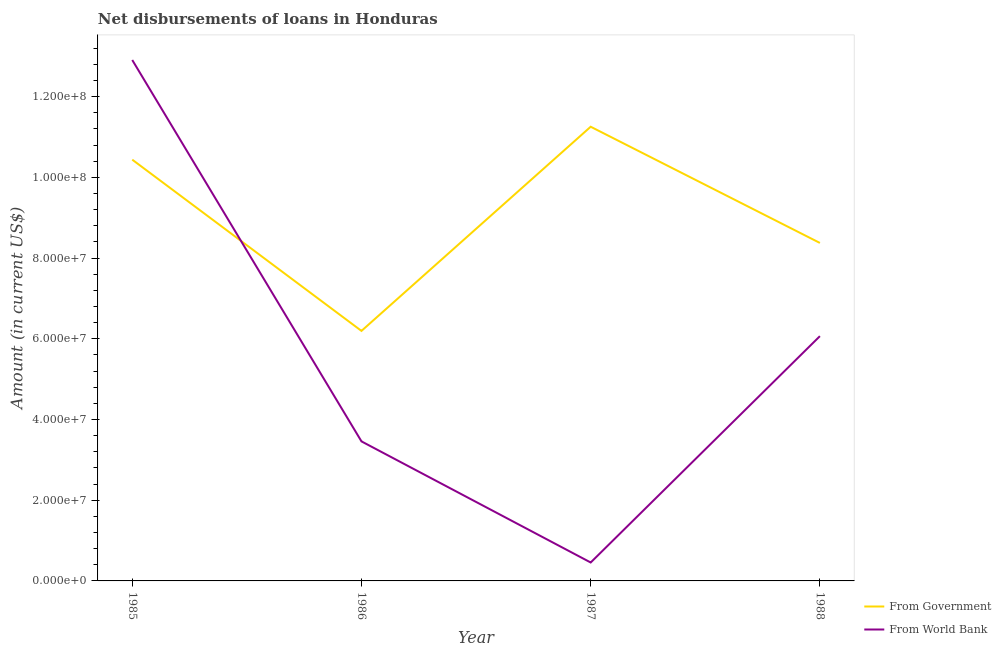How many different coloured lines are there?
Ensure brevity in your answer.  2. Does the line corresponding to net disbursements of loan from world bank intersect with the line corresponding to net disbursements of loan from government?
Give a very brief answer. Yes. Is the number of lines equal to the number of legend labels?
Your answer should be very brief. Yes. What is the net disbursements of loan from world bank in 1986?
Provide a short and direct response. 3.46e+07. Across all years, what is the maximum net disbursements of loan from world bank?
Ensure brevity in your answer.  1.29e+08. Across all years, what is the minimum net disbursements of loan from world bank?
Your answer should be very brief. 4.57e+06. In which year was the net disbursements of loan from world bank maximum?
Your response must be concise. 1985. In which year was the net disbursements of loan from world bank minimum?
Your answer should be very brief. 1987. What is the total net disbursements of loan from world bank in the graph?
Provide a short and direct response. 2.29e+08. What is the difference between the net disbursements of loan from government in 1985 and that in 1987?
Give a very brief answer. -8.16e+06. What is the difference between the net disbursements of loan from world bank in 1986 and the net disbursements of loan from government in 1987?
Ensure brevity in your answer.  -7.80e+07. What is the average net disbursements of loan from government per year?
Provide a short and direct response. 9.07e+07. In the year 1986, what is the difference between the net disbursements of loan from government and net disbursements of loan from world bank?
Your answer should be compact. 2.74e+07. What is the ratio of the net disbursements of loan from world bank in 1985 to that in 1988?
Provide a short and direct response. 2.13. Is the net disbursements of loan from government in 1987 less than that in 1988?
Make the answer very short. No. Is the difference between the net disbursements of loan from world bank in 1985 and 1986 greater than the difference between the net disbursements of loan from government in 1985 and 1986?
Offer a very short reply. Yes. What is the difference between the highest and the second highest net disbursements of loan from world bank?
Provide a short and direct response. 6.84e+07. What is the difference between the highest and the lowest net disbursements of loan from world bank?
Your answer should be very brief. 1.25e+08. In how many years, is the net disbursements of loan from world bank greater than the average net disbursements of loan from world bank taken over all years?
Offer a very short reply. 2. Is the sum of the net disbursements of loan from world bank in 1987 and 1988 greater than the maximum net disbursements of loan from government across all years?
Provide a short and direct response. No. How many lines are there?
Offer a terse response. 2. How many years are there in the graph?
Make the answer very short. 4. What is the difference between two consecutive major ticks on the Y-axis?
Provide a short and direct response. 2.00e+07. Are the values on the major ticks of Y-axis written in scientific E-notation?
Your answer should be compact. Yes. Does the graph contain any zero values?
Your answer should be compact. No. Does the graph contain grids?
Your response must be concise. No. How many legend labels are there?
Offer a terse response. 2. How are the legend labels stacked?
Your response must be concise. Vertical. What is the title of the graph?
Ensure brevity in your answer.  Net disbursements of loans in Honduras. Does "Lowest 20% of population" appear as one of the legend labels in the graph?
Keep it short and to the point. No. What is the Amount (in current US$) in From Government in 1985?
Offer a terse response. 1.04e+08. What is the Amount (in current US$) in From World Bank in 1985?
Provide a short and direct response. 1.29e+08. What is the Amount (in current US$) in From Government in 1986?
Provide a short and direct response. 6.20e+07. What is the Amount (in current US$) of From World Bank in 1986?
Your response must be concise. 3.46e+07. What is the Amount (in current US$) of From Government in 1987?
Provide a short and direct response. 1.13e+08. What is the Amount (in current US$) of From World Bank in 1987?
Offer a very short reply. 4.57e+06. What is the Amount (in current US$) in From Government in 1988?
Your answer should be very brief. 8.38e+07. What is the Amount (in current US$) of From World Bank in 1988?
Keep it short and to the point. 6.07e+07. Across all years, what is the maximum Amount (in current US$) of From Government?
Make the answer very short. 1.13e+08. Across all years, what is the maximum Amount (in current US$) in From World Bank?
Ensure brevity in your answer.  1.29e+08. Across all years, what is the minimum Amount (in current US$) of From Government?
Offer a very short reply. 6.20e+07. Across all years, what is the minimum Amount (in current US$) of From World Bank?
Provide a succinct answer. 4.57e+06. What is the total Amount (in current US$) in From Government in the graph?
Give a very brief answer. 3.63e+08. What is the total Amount (in current US$) of From World Bank in the graph?
Your response must be concise. 2.29e+08. What is the difference between the Amount (in current US$) in From Government in 1985 and that in 1986?
Ensure brevity in your answer.  4.24e+07. What is the difference between the Amount (in current US$) in From World Bank in 1985 and that in 1986?
Make the answer very short. 9.45e+07. What is the difference between the Amount (in current US$) in From Government in 1985 and that in 1987?
Your answer should be very brief. -8.16e+06. What is the difference between the Amount (in current US$) in From World Bank in 1985 and that in 1987?
Provide a short and direct response. 1.25e+08. What is the difference between the Amount (in current US$) of From Government in 1985 and that in 1988?
Offer a terse response. 2.06e+07. What is the difference between the Amount (in current US$) of From World Bank in 1985 and that in 1988?
Ensure brevity in your answer.  6.84e+07. What is the difference between the Amount (in current US$) of From Government in 1986 and that in 1987?
Provide a short and direct response. -5.06e+07. What is the difference between the Amount (in current US$) in From World Bank in 1986 and that in 1987?
Offer a very short reply. 3.00e+07. What is the difference between the Amount (in current US$) in From Government in 1986 and that in 1988?
Make the answer very short. -2.18e+07. What is the difference between the Amount (in current US$) of From World Bank in 1986 and that in 1988?
Your answer should be compact. -2.61e+07. What is the difference between the Amount (in current US$) in From Government in 1987 and that in 1988?
Offer a very short reply. 2.88e+07. What is the difference between the Amount (in current US$) in From World Bank in 1987 and that in 1988?
Your response must be concise. -5.61e+07. What is the difference between the Amount (in current US$) in From Government in 1985 and the Amount (in current US$) in From World Bank in 1986?
Offer a very short reply. 6.98e+07. What is the difference between the Amount (in current US$) of From Government in 1985 and the Amount (in current US$) of From World Bank in 1987?
Offer a very short reply. 9.98e+07. What is the difference between the Amount (in current US$) in From Government in 1985 and the Amount (in current US$) in From World Bank in 1988?
Your answer should be very brief. 4.37e+07. What is the difference between the Amount (in current US$) of From Government in 1986 and the Amount (in current US$) of From World Bank in 1987?
Your answer should be very brief. 5.74e+07. What is the difference between the Amount (in current US$) of From Government in 1986 and the Amount (in current US$) of From World Bank in 1988?
Give a very brief answer. 1.30e+06. What is the difference between the Amount (in current US$) of From Government in 1987 and the Amount (in current US$) of From World Bank in 1988?
Offer a terse response. 5.19e+07. What is the average Amount (in current US$) in From Government per year?
Offer a terse response. 9.07e+07. What is the average Amount (in current US$) in From World Bank per year?
Your answer should be compact. 5.72e+07. In the year 1985, what is the difference between the Amount (in current US$) in From Government and Amount (in current US$) in From World Bank?
Your response must be concise. -2.47e+07. In the year 1986, what is the difference between the Amount (in current US$) of From Government and Amount (in current US$) of From World Bank?
Give a very brief answer. 2.74e+07. In the year 1987, what is the difference between the Amount (in current US$) of From Government and Amount (in current US$) of From World Bank?
Make the answer very short. 1.08e+08. In the year 1988, what is the difference between the Amount (in current US$) in From Government and Amount (in current US$) in From World Bank?
Make the answer very short. 2.31e+07. What is the ratio of the Amount (in current US$) in From Government in 1985 to that in 1986?
Ensure brevity in your answer.  1.69. What is the ratio of the Amount (in current US$) in From World Bank in 1985 to that in 1986?
Provide a succinct answer. 3.73. What is the ratio of the Amount (in current US$) in From Government in 1985 to that in 1987?
Give a very brief answer. 0.93. What is the ratio of the Amount (in current US$) in From World Bank in 1985 to that in 1987?
Offer a very short reply. 28.26. What is the ratio of the Amount (in current US$) of From Government in 1985 to that in 1988?
Your response must be concise. 1.25. What is the ratio of the Amount (in current US$) in From World Bank in 1985 to that in 1988?
Your answer should be very brief. 2.13. What is the ratio of the Amount (in current US$) of From Government in 1986 to that in 1987?
Keep it short and to the point. 0.55. What is the ratio of the Amount (in current US$) of From World Bank in 1986 to that in 1987?
Make the answer very short. 7.57. What is the ratio of the Amount (in current US$) in From Government in 1986 to that in 1988?
Ensure brevity in your answer.  0.74. What is the ratio of the Amount (in current US$) in From World Bank in 1986 to that in 1988?
Your answer should be very brief. 0.57. What is the ratio of the Amount (in current US$) in From Government in 1987 to that in 1988?
Your answer should be very brief. 1.34. What is the ratio of the Amount (in current US$) in From World Bank in 1987 to that in 1988?
Provide a succinct answer. 0.08. What is the difference between the highest and the second highest Amount (in current US$) in From Government?
Provide a succinct answer. 8.16e+06. What is the difference between the highest and the second highest Amount (in current US$) of From World Bank?
Offer a very short reply. 6.84e+07. What is the difference between the highest and the lowest Amount (in current US$) of From Government?
Your answer should be very brief. 5.06e+07. What is the difference between the highest and the lowest Amount (in current US$) in From World Bank?
Your answer should be compact. 1.25e+08. 